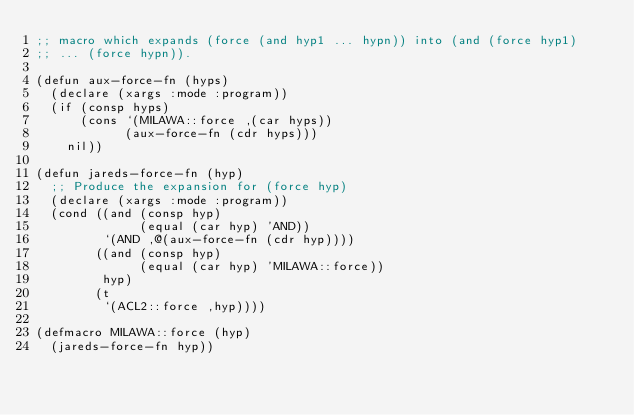<code> <loc_0><loc_0><loc_500><loc_500><_Lisp_>;; macro which expands (force (and hyp1 ... hypn)) into (and (force hyp1)
;; ... (force hypn)).

(defun aux-force-fn (hyps)
  (declare (xargs :mode :program))
  (if (consp hyps)
      (cons `(MILAWA::force ,(car hyps))
            (aux-force-fn (cdr hyps)))
    nil))

(defun jareds-force-fn (hyp)
  ;; Produce the expansion for (force hyp)
  (declare (xargs :mode :program))
  (cond ((and (consp hyp)
              (equal (car hyp) 'AND))
         `(AND ,@(aux-force-fn (cdr hyp))))
        ((and (consp hyp)
              (equal (car hyp) 'MILAWA::force))
         hyp)
        (t
         `(ACL2::force ,hyp))))

(defmacro MILAWA::force (hyp)
  (jareds-force-fn hyp))
</code> 